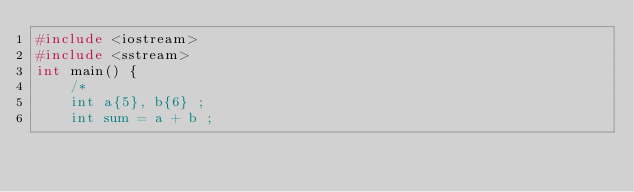<code> <loc_0><loc_0><loc_500><loc_500><_C++_>#include <iostream>
#include <sstream>
int main() {
	/*
	int a{5}, b{6} ;
	int sum = a + b ;</code> 